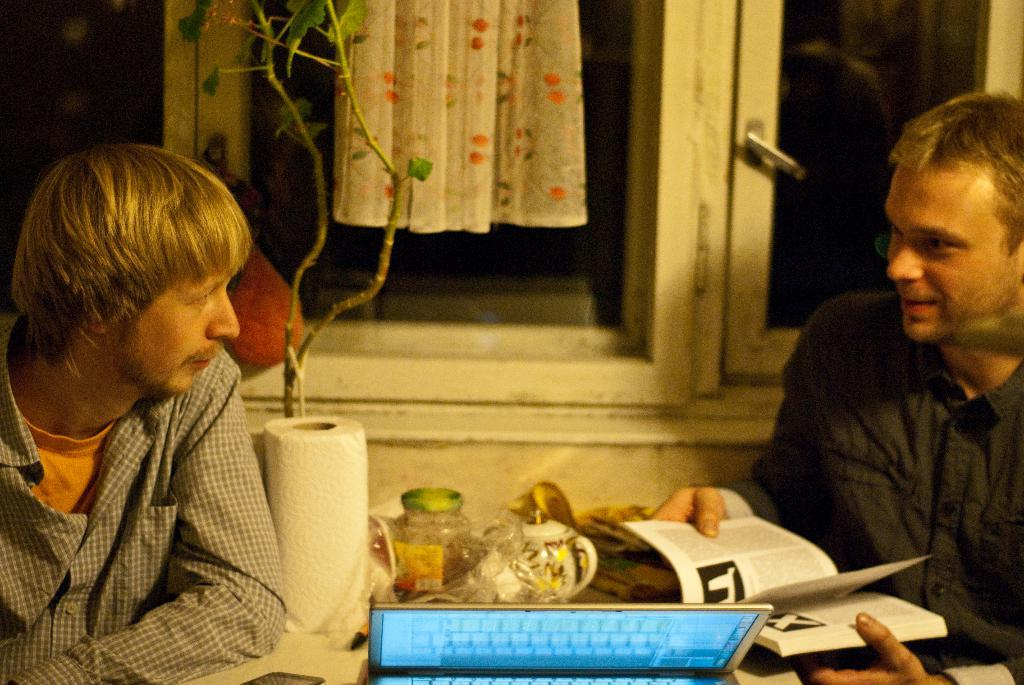What are the men in the image doing? The men are sitting in the image. What type of plant is visible in the image? There is a plant in the image. What object related to reading can be seen in the image? There is a book in the image. What electronic device is present in the image? There is a laptop in the image. What type of stationery item is visible in the image? There is a paper roll in the image. What can be found on the table in the image? There are items on the table in the image. What can be seen in the background of the image? There is a cloth and a window in the background of the image. How many pets are visible in the image? There are no pets visible in the image. What type of nest can be seen in the image? There is no nest present in the image. 